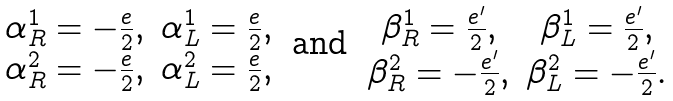<formula> <loc_0><loc_0><loc_500><loc_500>\begin{array} { c c } \alpha _ { R } ^ { 1 } = - \frac { e } { 2 } , & \alpha _ { L } ^ { 1 } = \frac { e } { 2 } , \\ \alpha _ { R } ^ { 2 } = - \frac { e } { 2 } , & \alpha _ { L } ^ { 2 } = \frac { e } { 2 } , \end{array} \text { and } \begin{array} { c c } \beta _ { R } ^ { 1 } = \frac { e ^ { \prime } } { 2 } , & \beta _ { L } ^ { 1 } = \frac { e ^ { \prime } } { 2 } , \\ \beta _ { R } ^ { 2 } = - \frac { e ^ { \prime } } { 2 } , & \beta _ { L } ^ { 2 } = - \frac { e ^ { \prime } } { 2 } . \end{array} \text { }</formula> 